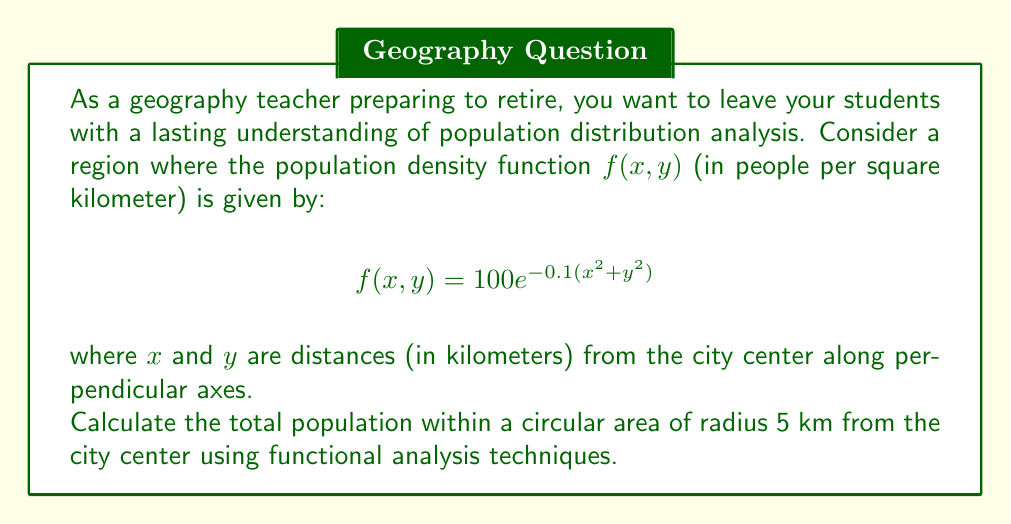Teach me how to tackle this problem. To solve this problem, we'll use functional analysis techniques, specifically integration in polar coordinates:

1) First, we need to convert the function from Cartesian to polar coordinates:
   $x = r\cos(\theta)$, $y = r\sin(\theta)$
   $x^2 + y^2 = r^2$

   So, $f(r,\theta) = 100e^{-0.1r^2}$

2) The total population is the volume under this surface within the given radius. We can calculate this using a double integral in polar coordinates:

   $$P = \int_{0}^{2\pi} \int_{0}^{5} f(r,\theta) r dr d\theta$$

3) Substituting our function:

   $$P = \int_{0}^{2\pi} \int_{0}^{5} 100e^{-0.1r^2} r dr d\theta$$

4) Since the function doesn't depend on $\theta$, we can separate the integrals:

   $$P = 2\pi \int_{0}^{5} 100re^{-0.1r^2} dr$$

5) To solve this integral, we can use the substitution $u = -0.1r^2$, $du = -0.2r dr$:

   $$P = 2\pi \cdot (-500) \int_{-2.5}^{0} e^u du$$

6) Evaluating the integral:

   $$P = 2\pi \cdot (-500) [e^u]_{-2.5}^{0} = 2\pi \cdot (-500) (1 - e^{-2.5})$$

7) Calculating the final result:

   $$P = 1000\pi(1 - e^{-2.5}) \approx 2763.85$$
Answer: The total population within a circular area of radius 5 km from the city center is approximately 2,764 people. 